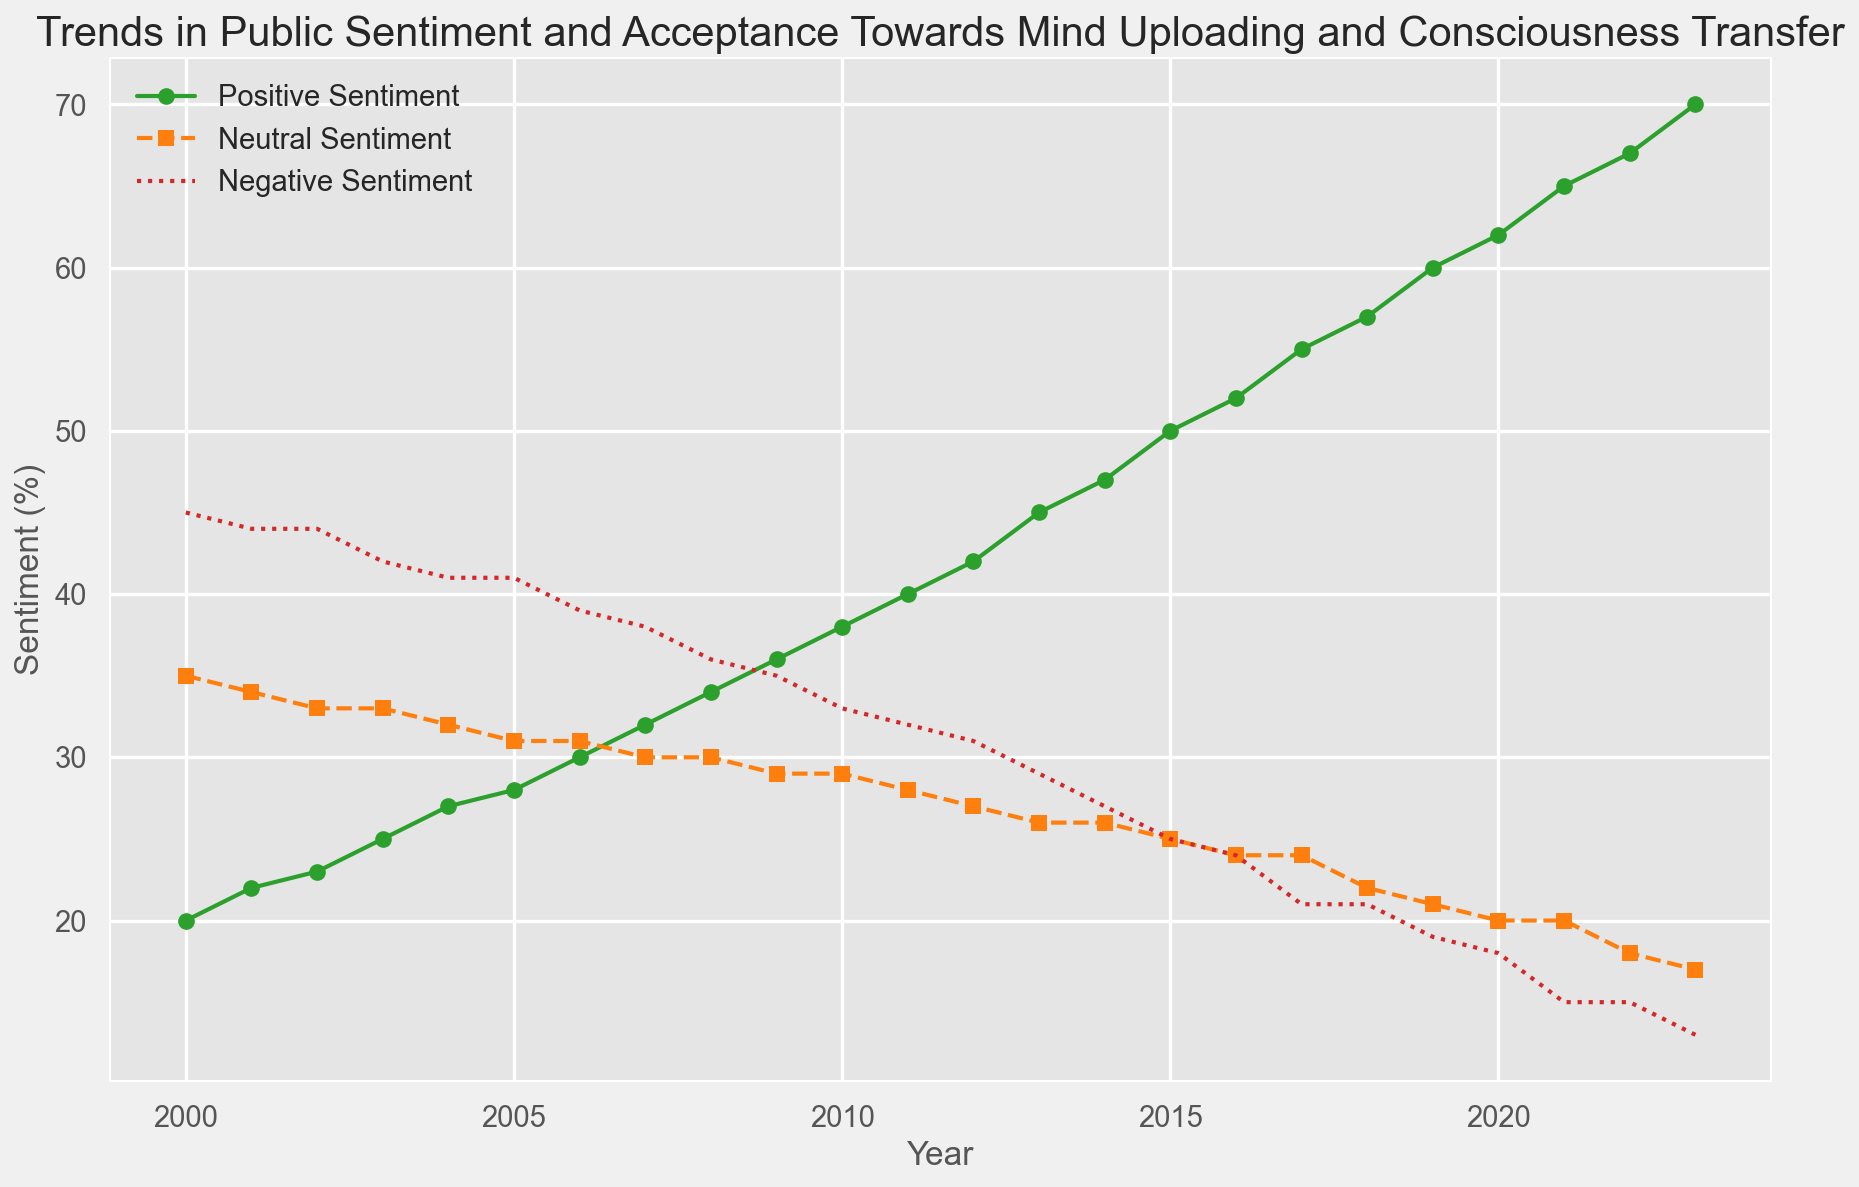What is the trend in positive sentiment from 2000 to 2023? The positive sentiment shows a steady increase from 20% in 2000 to 70% in 2023. This indicates growing acceptance over time.
Answer: Increasing How does negative sentiment in 2013 compare to 2023? In 2013, negative sentiment was 29%, while in 2023, it dropped to 13%. The sentiment decreased by 16 percentage points over this period.
Answer: Decreased by 16% What year shows the most significant increase in positive sentiment? The most significant increase in positive sentiment occurred between 2014 and 2015, where it rose from 47% to 50%, a 3 percentage point increase.
Answer: 2014 to 2015 What is the average positive sentiment in the first decade (2000-2009)? Sum the positive sentiment percentages from 2000 to 2009: (20 + 22 + 23 + 25 + 27 + 28 + 30 + 32 + 34 + 36) to get 277. Divide by 10 years to get an average of 27.7%.
Answer: 27.7% How do neutral sentiment trends visually compare to positive sentiment trends? Neutral sentiment declines steadily from 35% in 2000 to 17% in 2023, whereas positive sentiment increases from 20% to 70%. The two trends are inversely related.
Answer: Inversely related What percentage did negative sentiment decrease by from 2000 to 2023? Negative sentiment decreased from 45% in 2000 to 13% in 2023. The decrease is 45 - 13 = 32 percentage points.
Answer: 32 percentage points In which year were positive and negative sentiments equal? Positive and negative sentiments were equal in 2015, both at 25%.
Answer: 2015 Which sentiment showed the least variation over the years? Neutral sentiment showed the least variation, starting at 35% in 2000 and ending at 17% in 2023, with gradual decline.
Answer: Neutral sentiment What is the ratio of positive to negative sentiment in 2020? In 2020, positive sentiment is 62% and negative sentiment is 18%. The ratio is 62/18, which simplifies approximately to 3.44.
Answer: 3.44 If you sum the positive and neutral sentiments for 2023, what do you get? For 2023, positive sentiment is 70% and neutral sentiment is 17%. Sum them up to get 70 + 17 = 87%.
Answer: 87% 